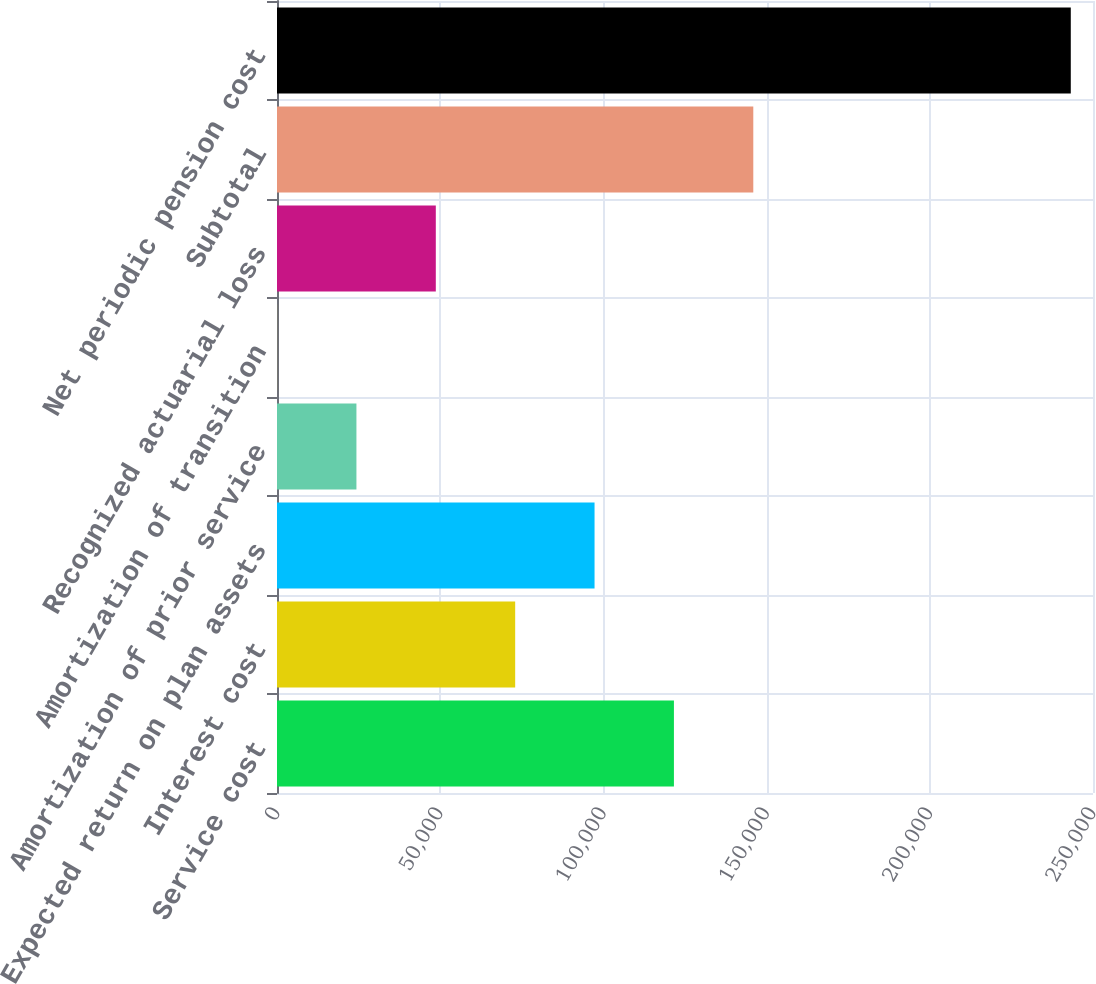Convert chart to OTSL. <chart><loc_0><loc_0><loc_500><loc_500><bar_chart><fcel>Service cost<fcel>Interest cost<fcel>Expected return on plan assets<fcel>Amortization of prior service<fcel>Amortization of transition<fcel>Recognized actuarial loss<fcel>Subtotal<fcel>Net periodic pension cost<nl><fcel>121606<fcel>72971.1<fcel>97288.8<fcel>24335.7<fcel>18<fcel>48653.4<fcel>145924<fcel>243195<nl></chart> 